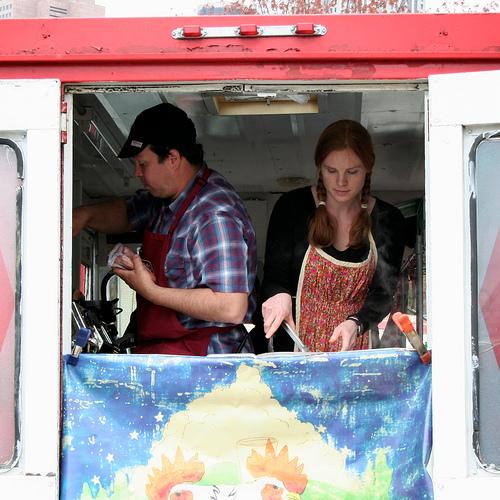Are they cooking?
Answer briefly. Yes. Are people busy?
Short answer required. Yes. Is this a food truck?
Short answer required. Yes. 